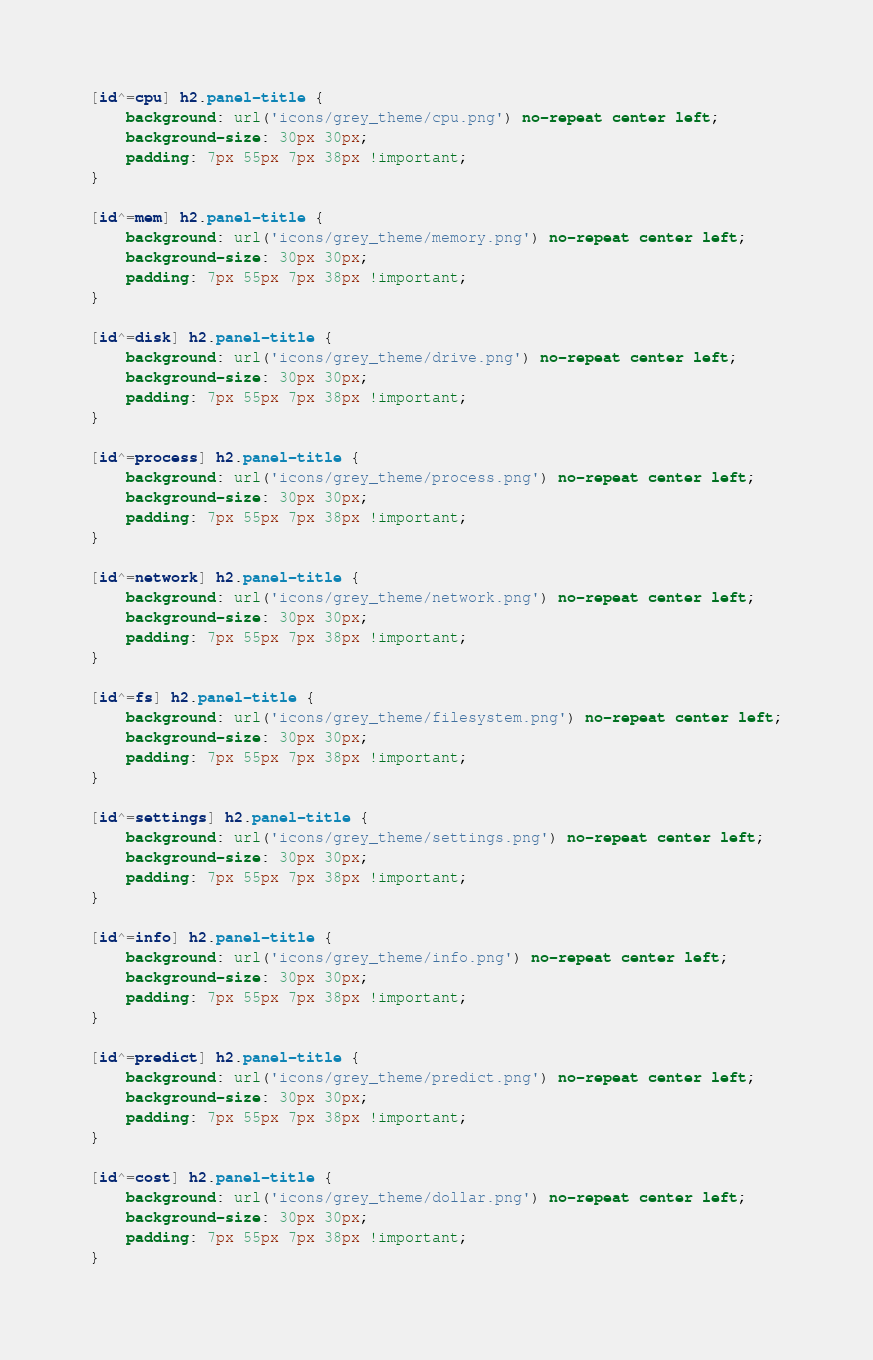Convert code to text. <code><loc_0><loc_0><loc_500><loc_500><_CSS_>
[id^=cpu] h2.panel-title {
	background: url('icons/grey_theme/cpu.png') no-repeat center left;
	background-size: 30px 30px;
    padding: 7px 55px 7px 38px !important;
}

[id^=mem] h2.panel-title {
	background: url('icons/grey_theme/memory.png') no-repeat center left;
	background-size: 30px 30px;
    padding: 7px 55px 7px 38px !important;
}

[id^=disk] h2.panel-title {
	background: url('icons/grey_theme/drive.png') no-repeat center left;
	background-size: 30px 30px;
    padding: 7px 55px 7px 38px !important;
}

[id^=process] h2.panel-title {
	background: url('icons/grey_theme/process.png') no-repeat center left;
	background-size: 30px 30px;
    padding: 7px 55px 7px 38px !important;
}

[id^=network] h2.panel-title {
	background: url('icons/grey_theme/network.png') no-repeat center left;
	background-size: 30px 30px;
    padding: 7px 55px 7px 38px !important;
}

[id^=fs] h2.panel-title {
	background: url('icons/grey_theme/filesystem.png') no-repeat center left;
	background-size: 30px 30px;
    padding: 7px 55px 7px 38px !important;
}

[id^=settings] h2.panel-title {
	background: url('icons/grey_theme/settings.png') no-repeat center left;
	background-size: 30px 30px;
    padding: 7px 55px 7px 38px !important;
}

[id^=info] h2.panel-title {
	background: url('icons/grey_theme/info.png') no-repeat center left;
	background-size: 30px 30px;
    padding: 7px 55px 7px 38px !important;
}

[id^=predict] h2.panel-title {
	background: url('icons/grey_theme/predict.png') no-repeat center left;
	background-size: 30px 30px;
    padding: 7px 55px 7px 38px !important;
}

[id^=cost] h2.panel-title {
	background: url('icons/grey_theme/dollar.png') no-repeat center left;
	background-size: 30px 30px;
    padding: 7px 55px 7px 38px !important;
}
</code> 